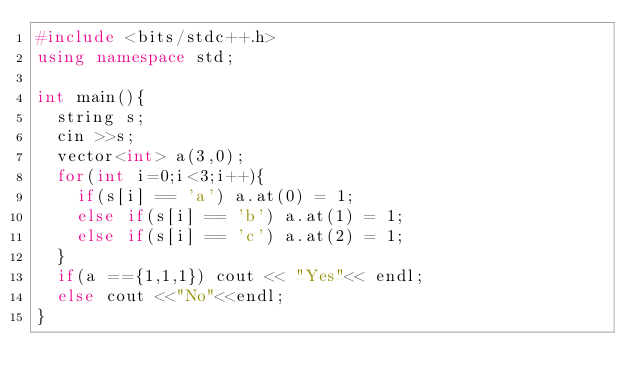Convert code to text. <code><loc_0><loc_0><loc_500><loc_500><_C++_>#include <bits/stdc++.h>
using namespace std;

int main(){
  string s;
  cin >>s;
  vector<int> a(3,0);
  for(int i=0;i<3;i++){
    if(s[i] == 'a') a.at(0) = 1;
    else if(s[i] == 'b') a.at(1) = 1;
    else if(s[i] == 'c') a.at(2) = 1;
  }
  if(a =={1,1,1}) cout << "Yes"<< endl;
  else cout <<"No"<<endl;
}</code> 